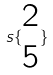Convert formula to latex. <formula><loc_0><loc_0><loc_500><loc_500>s \{ \begin{matrix} 2 \\ 5 \end{matrix} \}</formula> 